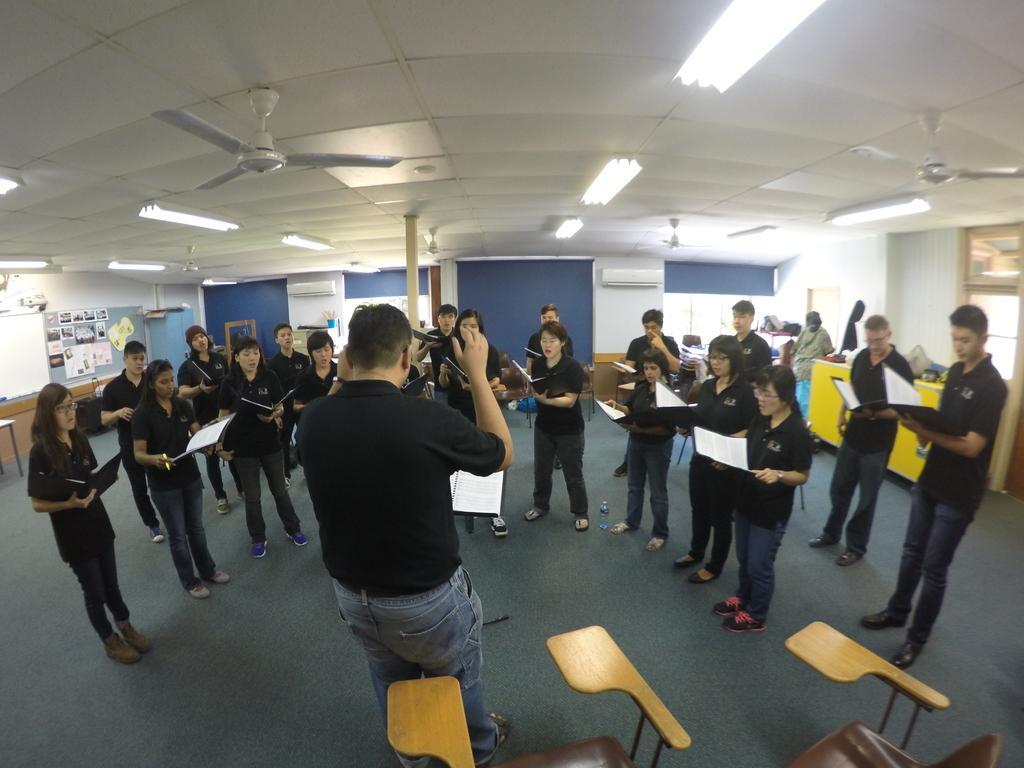How would you summarize this image in a sentence or two? In this image there is a man in the middle. In front of him there are group of people who are standing on the floor by holding the books. Behind the man there are chairs. At the top there is ceiling with the lights. In the background there is a wall which has two air conditioners. On the left side there is a board on which there are articles. 